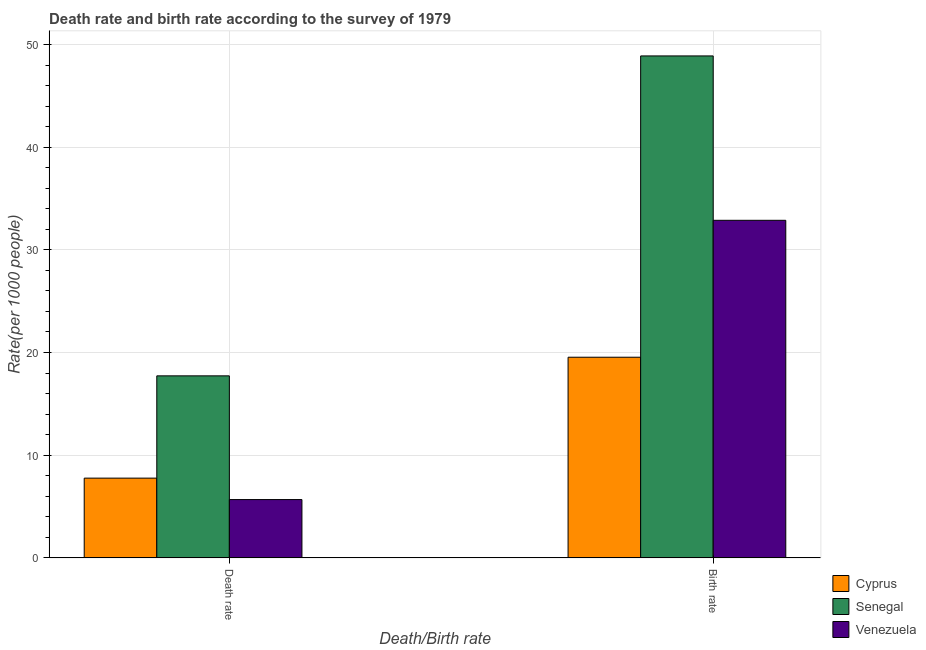How many bars are there on the 2nd tick from the right?
Your response must be concise. 3. What is the label of the 2nd group of bars from the left?
Offer a very short reply. Birth rate. What is the birth rate in Senegal?
Provide a short and direct response. 48.88. Across all countries, what is the maximum death rate?
Offer a terse response. 17.73. Across all countries, what is the minimum death rate?
Ensure brevity in your answer.  5.68. In which country was the birth rate maximum?
Ensure brevity in your answer.  Senegal. In which country was the birth rate minimum?
Your response must be concise. Cyprus. What is the total birth rate in the graph?
Your response must be concise. 101.31. What is the difference between the birth rate in Senegal and that in Cyprus?
Your answer should be very brief. 29.34. What is the difference between the death rate in Cyprus and the birth rate in Senegal?
Provide a succinct answer. -41.12. What is the average birth rate per country?
Give a very brief answer. 33.77. What is the difference between the death rate and birth rate in Cyprus?
Ensure brevity in your answer.  -11.77. In how many countries, is the birth rate greater than 48 ?
Give a very brief answer. 1. What is the ratio of the death rate in Senegal to that in Cyprus?
Provide a succinct answer. 2.28. Is the death rate in Cyprus less than that in Venezuela?
Your answer should be compact. No. In how many countries, is the birth rate greater than the average birth rate taken over all countries?
Your answer should be very brief. 1. What does the 2nd bar from the left in Death rate represents?
Offer a terse response. Senegal. What does the 3rd bar from the right in Birth rate represents?
Ensure brevity in your answer.  Cyprus. How many bars are there?
Provide a short and direct response. 6. What is the difference between two consecutive major ticks on the Y-axis?
Keep it short and to the point. 10. Are the values on the major ticks of Y-axis written in scientific E-notation?
Ensure brevity in your answer.  No. Does the graph contain grids?
Your response must be concise. Yes. How many legend labels are there?
Keep it short and to the point. 3. What is the title of the graph?
Provide a succinct answer. Death rate and birth rate according to the survey of 1979. What is the label or title of the X-axis?
Offer a very short reply. Death/Birth rate. What is the label or title of the Y-axis?
Make the answer very short. Rate(per 1000 people). What is the Rate(per 1000 people) of Cyprus in Death rate?
Offer a very short reply. 7.77. What is the Rate(per 1000 people) in Senegal in Death rate?
Offer a very short reply. 17.73. What is the Rate(per 1000 people) in Venezuela in Death rate?
Make the answer very short. 5.68. What is the Rate(per 1000 people) of Cyprus in Birth rate?
Provide a short and direct response. 19.54. What is the Rate(per 1000 people) of Senegal in Birth rate?
Keep it short and to the point. 48.88. What is the Rate(per 1000 people) in Venezuela in Birth rate?
Keep it short and to the point. 32.88. Across all Death/Birth rate, what is the maximum Rate(per 1000 people) of Cyprus?
Offer a very short reply. 19.54. Across all Death/Birth rate, what is the maximum Rate(per 1000 people) of Senegal?
Give a very brief answer. 48.88. Across all Death/Birth rate, what is the maximum Rate(per 1000 people) of Venezuela?
Your answer should be compact. 32.88. Across all Death/Birth rate, what is the minimum Rate(per 1000 people) of Cyprus?
Provide a short and direct response. 7.77. Across all Death/Birth rate, what is the minimum Rate(per 1000 people) in Senegal?
Ensure brevity in your answer.  17.73. Across all Death/Birth rate, what is the minimum Rate(per 1000 people) in Venezuela?
Make the answer very short. 5.68. What is the total Rate(per 1000 people) in Cyprus in the graph?
Give a very brief answer. 27.31. What is the total Rate(per 1000 people) of Senegal in the graph?
Your answer should be very brief. 66.61. What is the total Rate(per 1000 people) of Venezuela in the graph?
Offer a terse response. 38.56. What is the difference between the Rate(per 1000 people) of Cyprus in Death rate and that in Birth rate?
Provide a succinct answer. -11.78. What is the difference between the Rate(per 1000 people) of Senegal in Death rate and that in Birth rate?
Provide a succinct answer. -31.16. What is the difference between the Rate(per 1000 people) of Venezuela in Death rate and that in Birth rate?
Provide a short and direct response. -27.2. What is the difference between the Rate(per 1000 people) in Cyprus in Death rate and the Rate(per 1000 people) in Senegal in Birth rate?
Provide a succinct answer. -41.12. What is the difference between the Rate(per 1000 people) in Cyprus in Death rate and the Rate(per 1000 people) in Venezuela in Birth rate?
Make the answer very short. -25.11. What is the difference between the Rate(per 1000 people) in Senegal in Death rate and the Rate(per 1000 people) in Venezuela in Birth rate?
Make the answer very short. -15.15. What is the average Rate(per 1000 people) in Cyprus per Death/Birth rate?
Your answer should be compact. 13.66. What is the average Rate(per 1000 people) of Senegal per Death/Birth rate?
Your response must be concise. 33.31. What is the average Rate(per 1000 people) of Venezuela per Death/Birth rate?
Offer a terse response. 19.28. What is the difference between the Rate(per 1000 people) in Cyprus and Rate(per 1000 people) in Senegal in Death rate?
Your response must be concise. -9.96. What is the difference between the Rate(per 1000 people) in Cyprus and Rate(per 1000 people) in Venezuela in Death rate?
Give a very brief answer. 2.09. What is the difference between the Rate(per 1000 people) of Senegal and Rate(per 1000 people) of Venezuela in Death rate?
Your answer should be compact. 12.05. What is the difference between the Rate(per 1000 people) in Cyprus and Rate(per 1000 people) in Senegal in Birth rate?
Give a very brief answer. -29.34. What is the difference between the Rate(per 1000 people) of Cyprus and Rate(per 1000 people) of Venezuela in Birth rate?
Make the answer very short. -13.33. What is the difference between the Rate(per 1000 people) of Senegal and Rate(per 1000 people) of Venezuela in Birth rate?
Give a very brief answer. 16.01. What is the ratio of the Rate(per 1000 people) of Cyprus in Death rate to that in Birth rate?
Provide a succinct answer. 0.4. What is the ratio of the Rate(per 1000 people) of Senegal in Death rate to that in Birth rate?
Provide a succinct answer. 0.36. What is the ratio of the Rate(per 1000 people) in Venezuela in Death rate to that in Birth rate?
Your answer should be very brief. 0.17. What is the difference between the highest and the second highest Rate(per 1000 people) of Cyprus?
Offer a very short reply. 11.78. What is the difference between the highest and the second highest Rate(per 1000 people) of Senegal?
Offer a very short reply. 31.16. What is the difference between the highest and the second highest Rate(per 1000 people) in Venezuela?
Your answer should be very brief. 27.2. What is the difference between the highest and the lowest Rate(per 1000 people) of Cyprus?
Offer a terse response. 11.78. What is the difference between the highest and the lowest Rate(per 1000 people) in Senegal?
Ensure brevity in your answer.  31.16. What is the difference between the highest and the lowest Rate(per 1000 people) of Venezuela?
Your response must be concise. 27.2. 